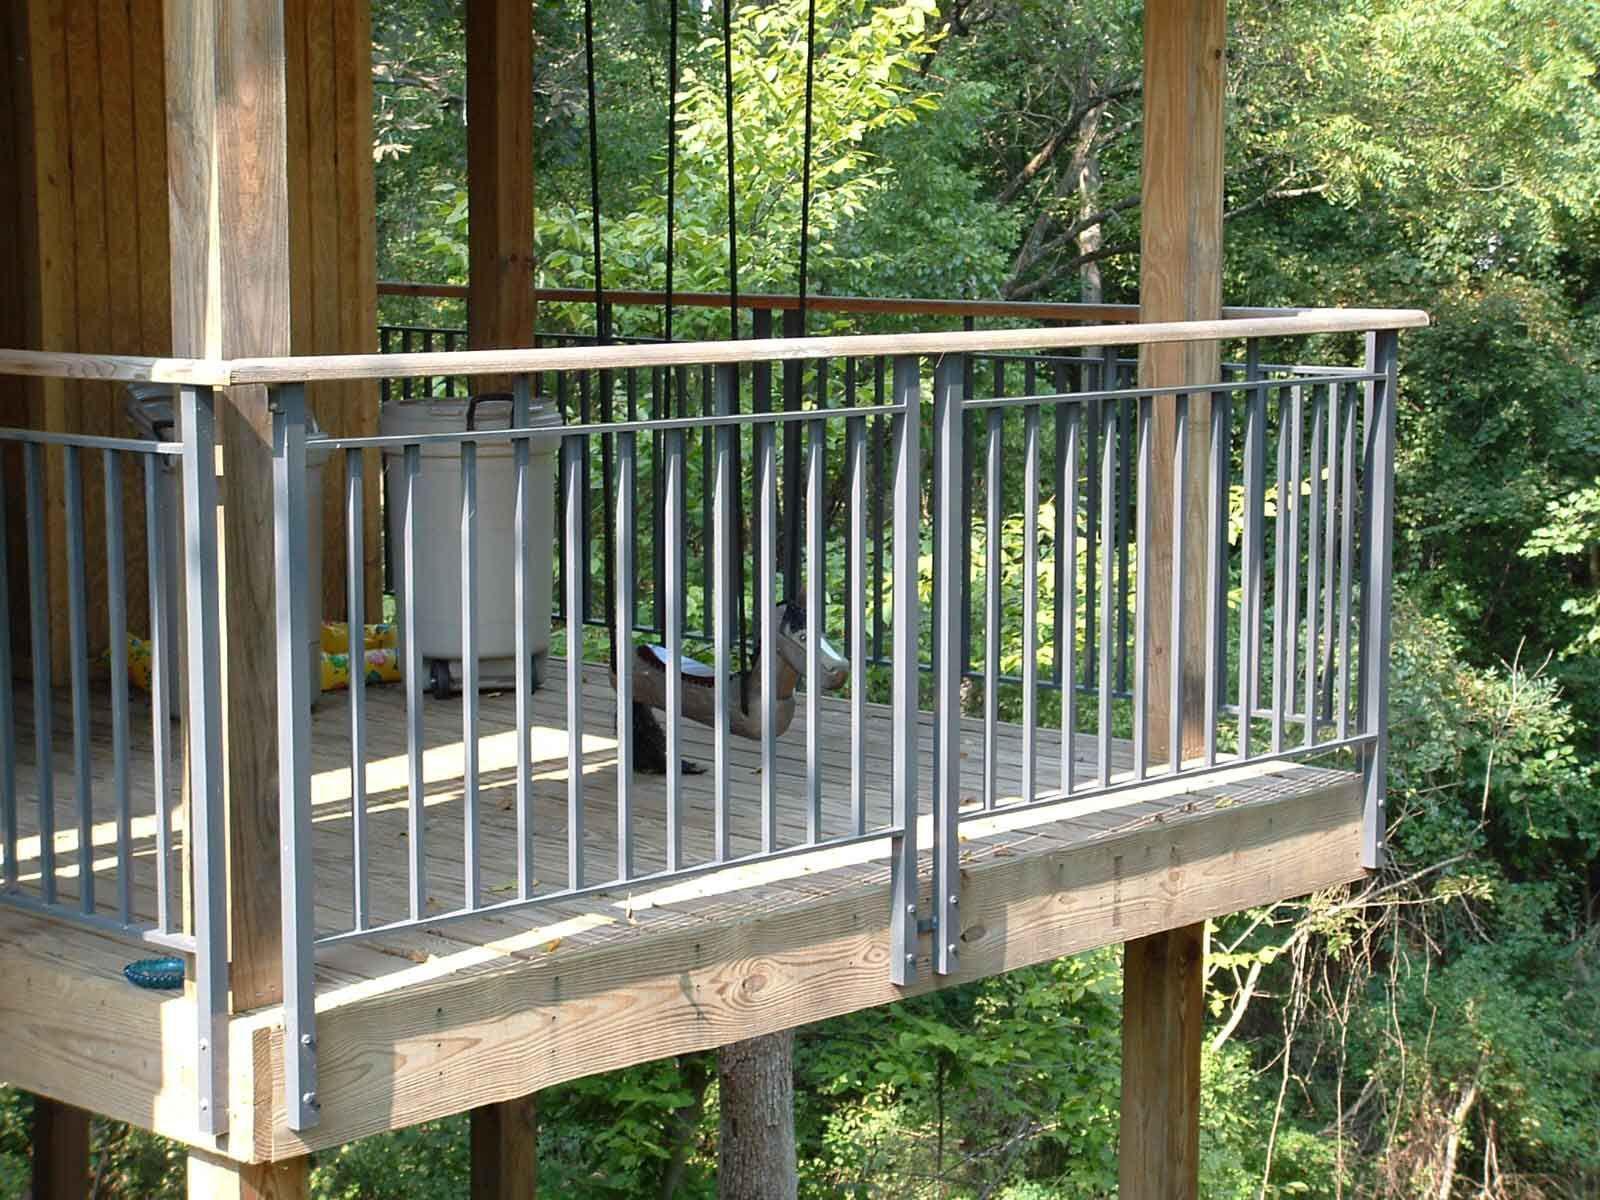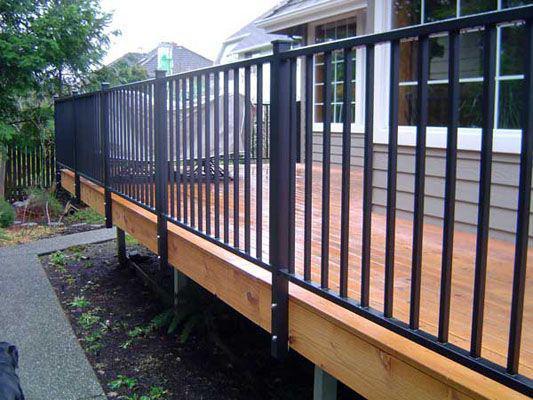The first image is the image on the left, the second image is the image on the right. Given the left and right images, does the statement "All the railing spindles are straight." hold true? Answer yes or no. Yes. The first image is the image on the left, the second image is the image on the right. Considering the images on both sides, is "Flowers and foliage are seen through curving black vertical rails mounted to light wood in both scenes." valid? Answer yes or no. No. 